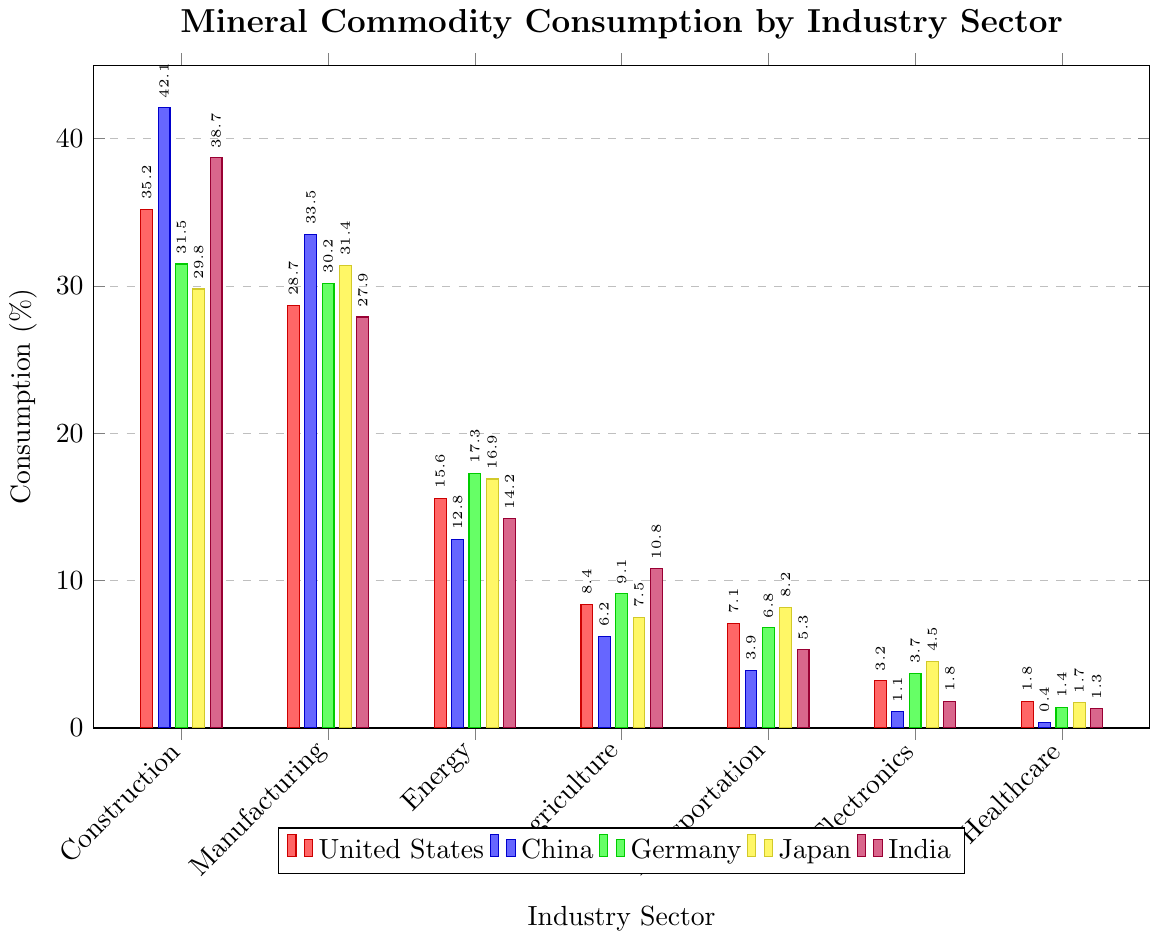Which industry sector has the highest mineral commodity consumption in China? The highest bar in the China series (blue) corresponds to the Construction sector with a value of 42.1%.
Answer: Construction (42.1%) Which industry has the lowest mineral commodity consumption in the United States? The lowest bar for the United States (red) is in the Healthcare sector with a value of 1.8%.
Answer: Healthcare (1.8%) What is the difference in mineral commodity consumption between the Construction and Manufacturing sectors in Germany? The Construction sector for Germany is 31.5% and the Manufacturing sector is 30.2%. The difference is 31.5% - 30.2% = 1.3%.
Answer: 1.3% Compare the Agriculture sector consumption for India and Japan. Which country consumes more? The bar for Agriculture in India (purple) is 10.8%, whereas in Japan (yellow) it is 7.5%. India consumes more.
Answer: India What is the total mineral commodity consumption of the Energy sector across all five countries? Sum the Energy sector consumption for each country: USA (15.6) + China (12.8) + Germany (17.3) + Japan (16.9) + India (14.2). The total is 15.6 + 12.8 + 17.3 + 16.9 + 14.2 = 76.8%.
Answer: 76.8% Which country has the highest mineral commodity consumption in the Electronics sector? The highest bar in the Electronics sector belongs to Japan (yellow) with a value of 4.5%.
Answer: Japan (4.5%) Rank the Healthcare sector consumption from highest to lowest for all five countries. United States: 1.8%, Germany: 1.4%, Japan: 1.7%, India: 1.3%, China: 0.4%. Ranking from highest to lowest: United States, Japan, Germany, India, China.
Answer: United States > Japan > Germany > India > China What is the average consumption of the Manufacturing sector for the five countries? Sum the Manufacturing sector consumption for each country: USA (28.7) + China (33.5) + Germany (30.2) + Japan (31.4) + India (27.9). The total is 28.7 + 33.5 + 30.2 + 31.4 + 27.9 = 151.7. The average is 151.7 / 5 = 30.34%.
Answer: 30.34% Is any sector's consumption in Japan exactly equal to 7.5%? The Agriculture sector in Japan has a bar representing a consumption of 7.5%.
Answer: Yes Between the United States and Germany, which country has a higher consumption in the Transportation sector and by how much? The United States and Germany have values of 7.1% and 6.8% respectively in the Transportation sector. The difference is 7.1% - 6.8% = 0.3%.
Answer: United States by 0.3% 